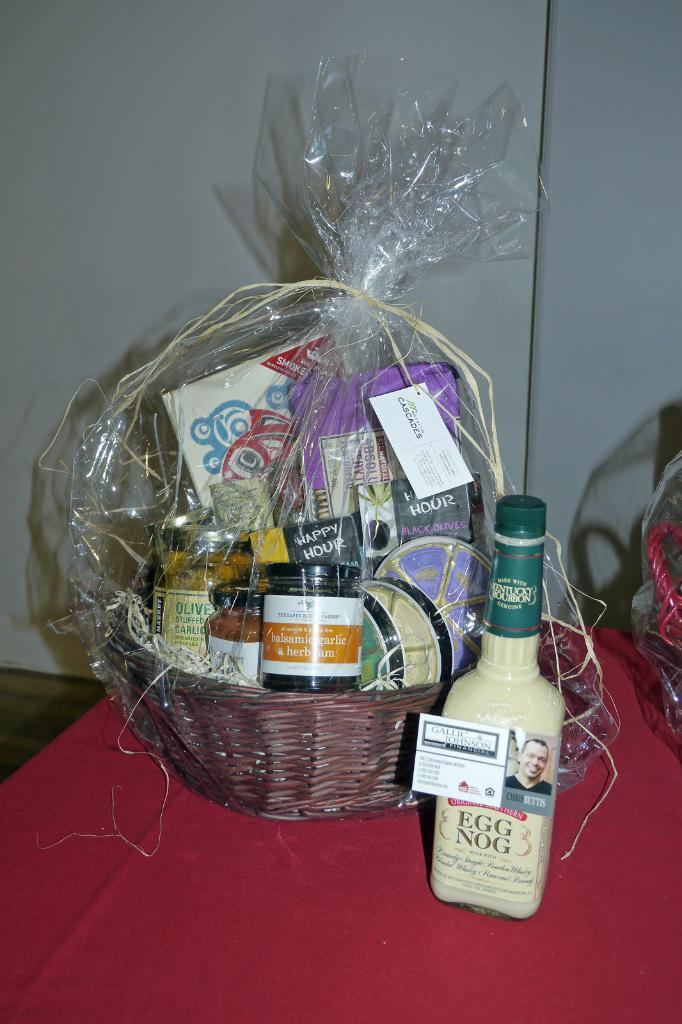<image>
Give a short and clear explanation of the subsequent image. Basket of items next to a bottle of Egg Nogg. 